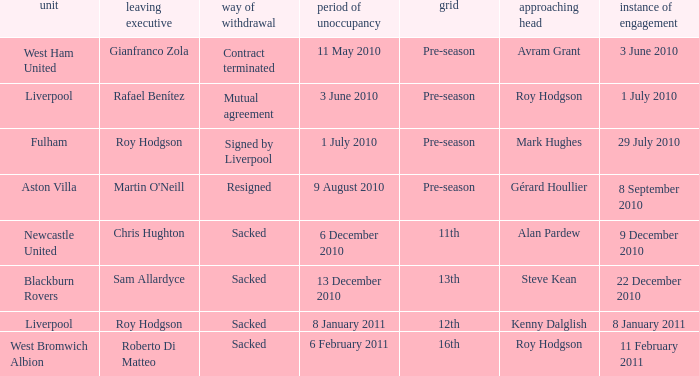What team has an incoming manager named Kenny Dalglish? Liverpool. 